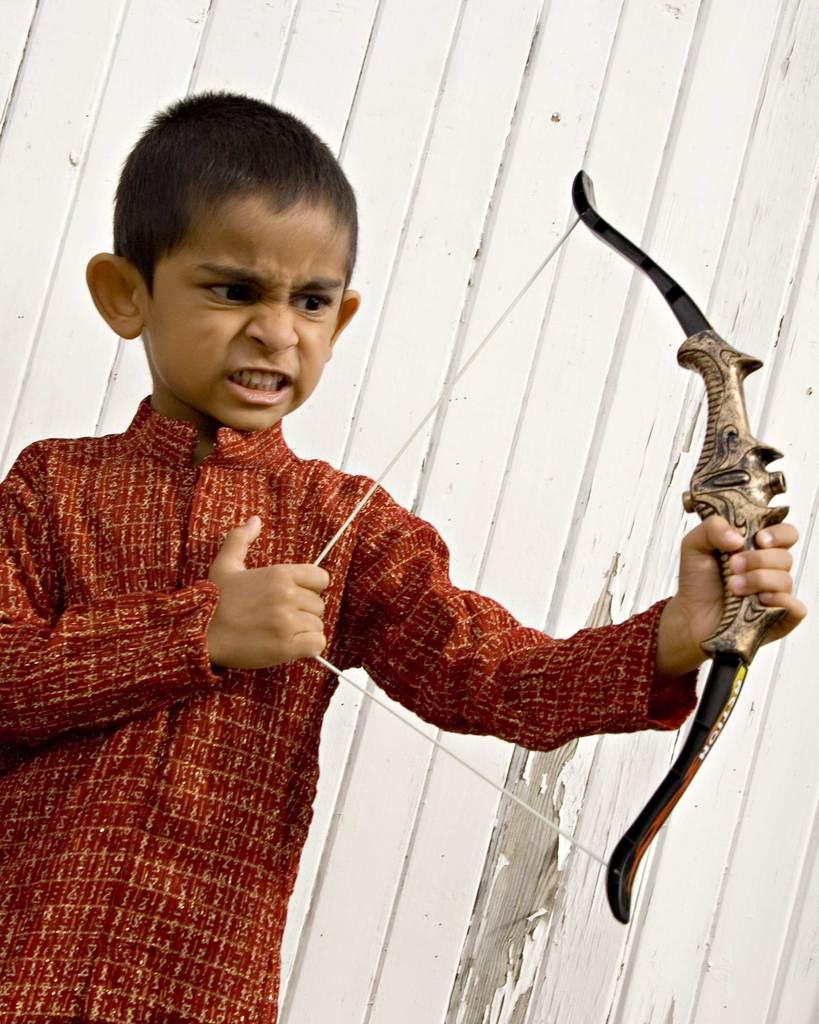What is the main subject of the image? The main subject of the image is a boy. What is the boy holding in the image? The boy is holding a bow in the image. What can be seen in the background of the image? There is a wall in the background of the image. What type of jeans is the boy wearing in the image? There is no information about the boy's jeans in the image, so we cannot determine what type he is wearing. 